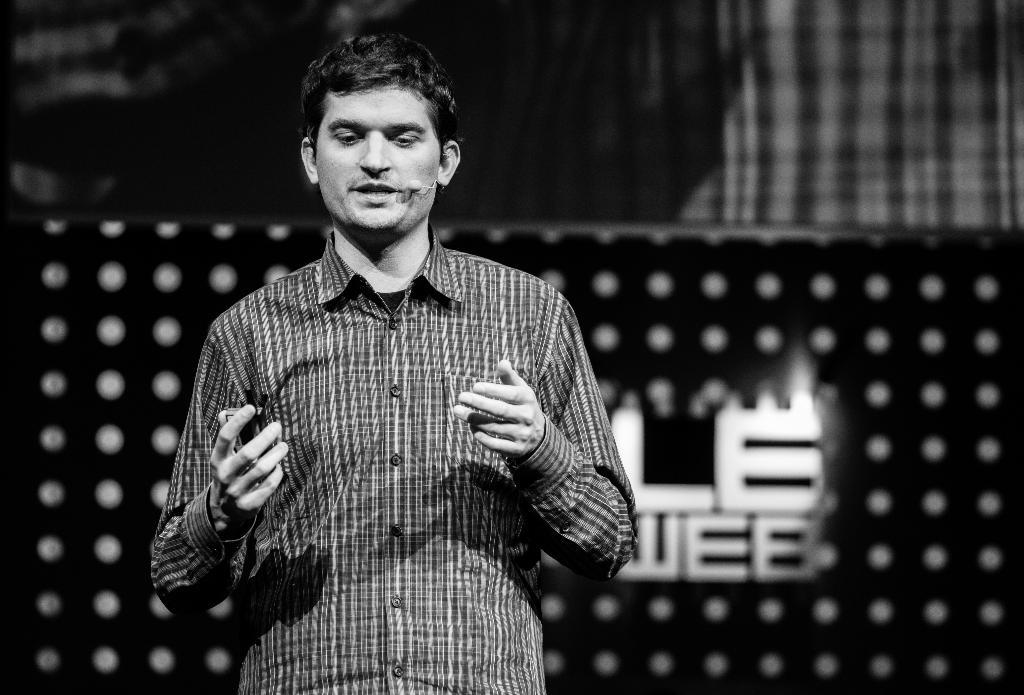What is the color scheme of the image? The image is black and white. Who is present in the image? There is a man in the image. What is the man doing in the image? The man is standing. What is the man wearing in the image? The man is wearing a checked shirt. What else can be seen in the image besides the man? There is a banner in the image. What type of unit can be seen in the image? There is no unit present in the image. Is there a zoo in the background of the image? There is no mention of a zoo or any animals in the image. 